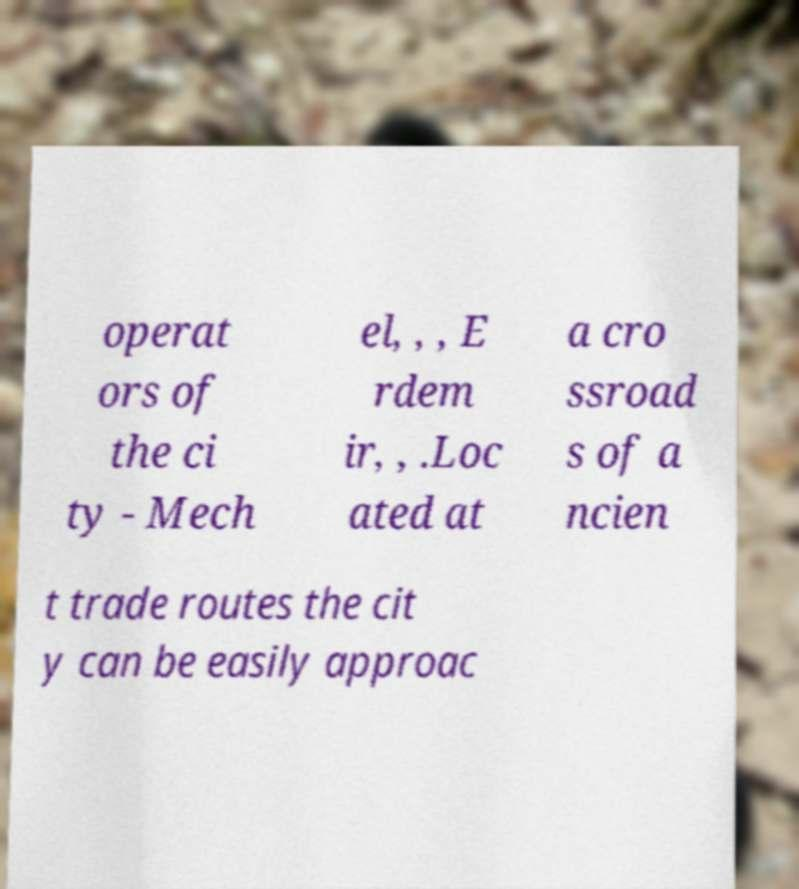I need the written content from this picture converted into text. Can you do that? operat ors of the ci ty - Mech el, , , E rdem ir, , .Loc ated at a cro ssroad s of a ncien t trade routes the cit y can be easily approac 